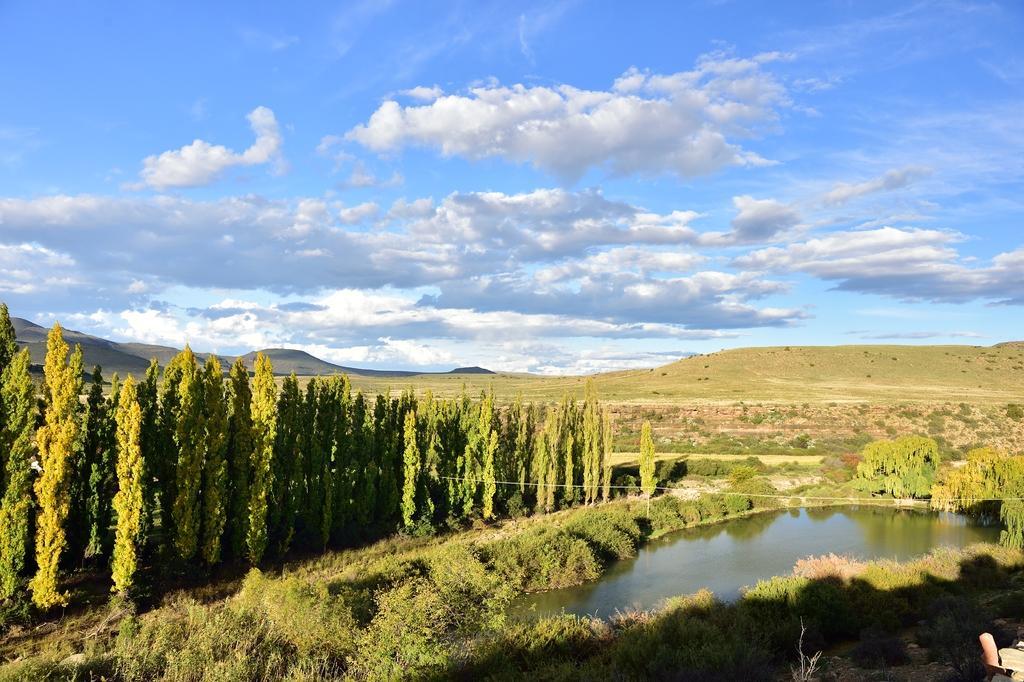Describe this image in one or two sentences. As we can see in the image there are trees, grass, water, sky and clouds. 